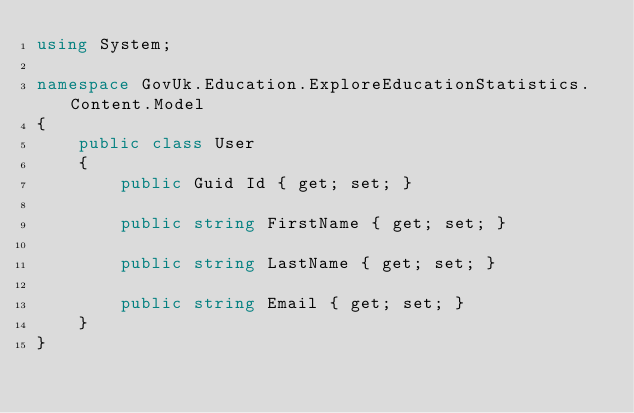<code> <loc_0><loc_0><loc_500><loc_500><_C#_>using System;

namespace GovUk.Education.ExploreEducationStatistics.Content.Model
{
    public class User
    {
        public Guid Id { get; set; }
        
        public string FirstName { get; set; }
        
        public string LastName { get; set; }
        
        public string Email { get; set; }
    }
}</code> 